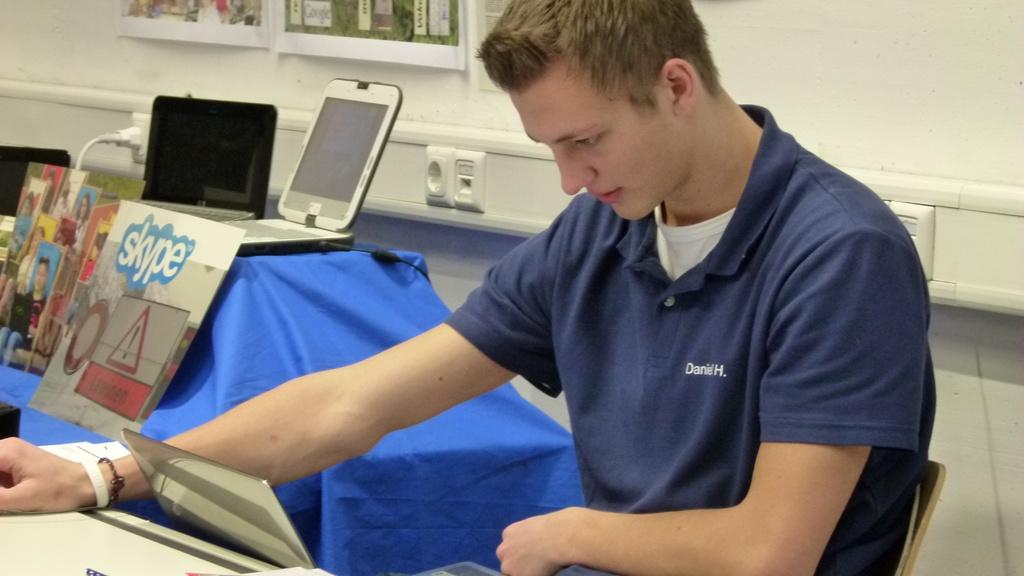<image>
Share a concise interpretation of the image provided. the name Daniel is on the front of the shirt 